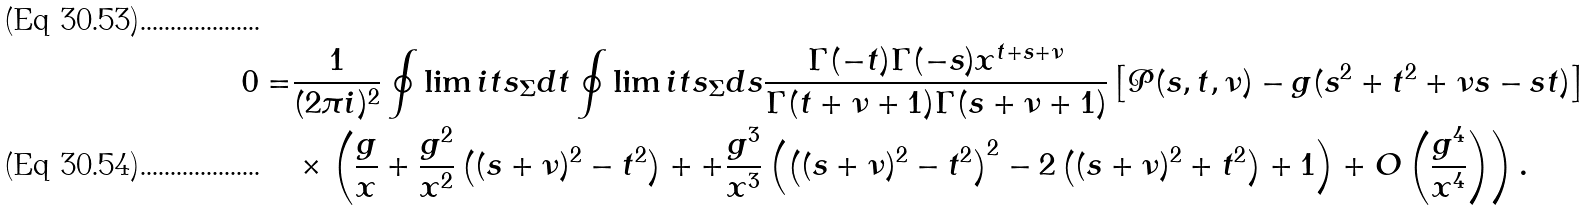<formula> <loc_0><loc_0><loc_500><loc_500>0 = & \frac { 1 } { ( 2 \pi i ) ^ { 2 } } \oint \lim i t s _ { \Sigma } d t \oint \lim i t s _ { \Sigma } d s \frac { \Gamma ( - t ) \Gamma ( - s ) x ^ { t + s + \nu } } { \Gamma ( t + \nu + 1 ) \Gamma ( s + \nu + 1 ) } \left [ \mathcal { P } ( s , t , \nu ) - g ( s ^ { 2 } + t ^ { 2 } + \nu s - s t ) \right ] \\ & \times \left ( \frac { g } { x } + \frac { g ^ { 2 } } { x ^ { 2 } } \left ( ( s + \nu ) ^ { 2 } - t ^ { 2 } \right ) + + \frac { g ^ { 3 } } { x ^ { 3 } } \left ( \left ( ( s + \nu ) ^ { 2 } - t ^ { 2 } \right ) ^ { 2 } - 2 \left ( ( s + \nu ) ^ { 2 } + t ^ { 2 } \right ) + 1 \right ) + O \left ( \frac { g ^ { 4 } } { x ^ { 4 } } \right ) \right ) .</formula> 